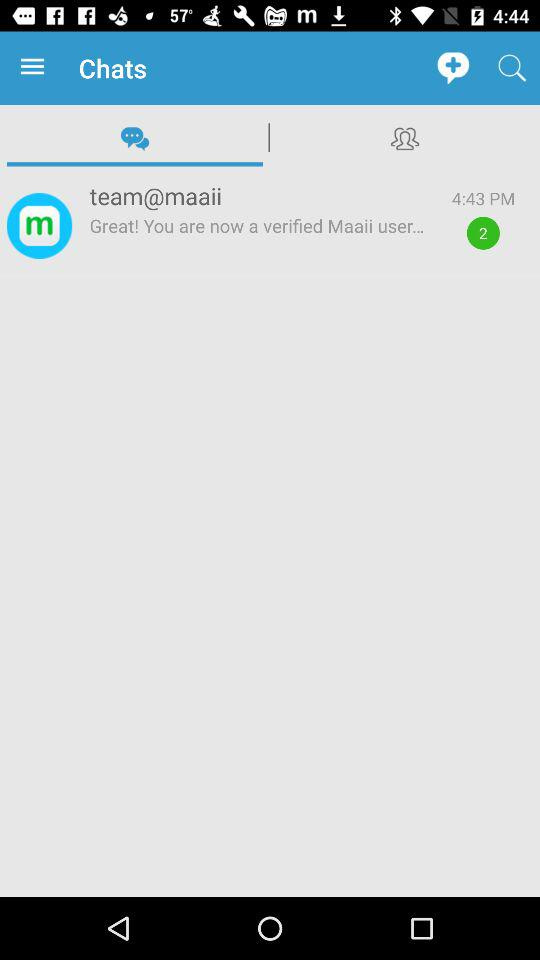How many unread messages are there? There are 2 unread messages. 